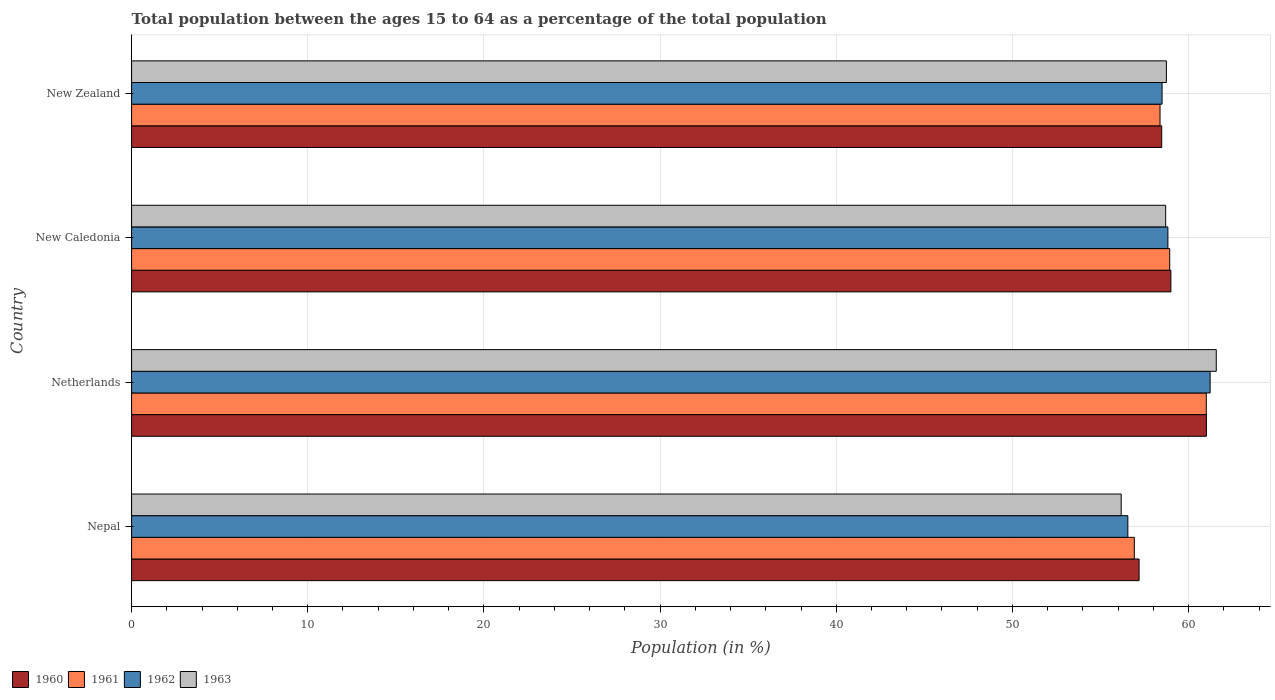Are the number of bars per tick equal to the number of legend labels?
Your answer should be compact. Yes. How many bars are there on the 2nd tick from the bottom?
Provide a short and direct response. 4. What is the label of the 2nd group of bars from the top?
Give a very brief answer. New Caledonia. In how many cases, is the number of bars for a given country not equal to the number of legend labels?
Your response must be concise. 0. What is the percentage of the population ages 15 to 64 in 1961 in New Caledonia?
Give a very brief answer. 58.93. Across all countries, what is the maximum percentage of the population ages 15 to 64 in 1963?
Ensure brevity in your answer.  61.57. Across all countries, what is the minimum percentage of the population ages 15 to 64 in 1962?
Your answer should be compact. 56.55. In which country was the percentage of the population ages 15 to 64 in 1961 maximum?
Give a very brief answer. Netherlands. In which country was the percentage of the population ages 15 to 64 in 1962 minimum?
Keep it short and to the point. Nepal. What is the total percentage of the population ages 15 to 64 in 1960 in the graph?
Keep it short and to the point. 235.67. What is the difference between the percentage of the population ages 15 to 64 in 1962 in New Caledonia and that in New Zealand?
Give a very brief answer. 0.33. What is the difference between the percentage of the population ages 15 to 64 in 1963 in Netherlands and the percentage of the population ages 15 to 64 in 1960 in Nepal?
Ensure brevity in your answer.  4.38. What is the average percentage of the population ages 15 to 64 in 1962 per country?
Ensure brevity in your answer.  58.77. What is the difference between the percentage of the population ages 15 to 64 in 1960 and percentage of the population ages 15 to 64 in 1961 in Nepal?
Provide a succinct answer. 0.27. What is the ratio of the percentage of the population ages 15 to 64 in 1962 in Netherlands to that in New Caledonia?
Offer a very short reply. 1.04. What is the difference between the highest and the second highest percentage of the population ages 15 to 64 in 1963?
Offer a very short reply. 2.83. What is the difference between the highest and the lowest percentage of the population ages 15 to 64 in 1963?
Give a very brief answer. 5.4. In how many countries, is the percentage of the population ages 15 to 64 in 1962 greater than the average percentage of the population ages 15 to 64 in 1962 taken over all countries?
Make the answer very short. 2. Is the sum of the percentage of the population ages 15 to 64 in 1960 in Nepal and New Zealand greater than the maximum percentage of the population ages 15 to 64 in 1962 across all countries?
Your response must be concise. Yes. Is it the case that in every country, the sum of the percentage of the population ages 15 to 64 in 1961 and percentage of the population ages 15 to 64 in 1963 is greater than the percentage of the population ages 15 to 64 in 1960?
Ensure brevity in your answer.  Yes. What is the difference between two consecutive major ticks on the X-axis?
Give a very brief answer. 10. Are the values on the major ticks of X-axis written in scientific E-notation?
Provide a short and direct response. No. How many legend labels are there?
Keep it short and to the point. 4. How are the legend labels stacked?
Your answer should be compact. Horizontal. What is the title of the graph?
Ensure brevity in your answer.  Total population between the ages 15 to 64 as a percentage of the total population. Does "1992" appear as one of the legend labels in the graph?
Make the answer very short. No. What is the label or title of the X-axis?
Provide a succinct answer. Population (in %). What is the Population (in %) of 1960 in Nepal?
Your answer should be compact. 57.19. What is the Population (in %) in 1961 in Nepal?
Ensure brevity in your answer.  56.92. What is the Population (in %) in 1962 in Nepal?
Offer a very short reply. 56.55. What is the Population (in %) of 1963 in Nepal?
Give a very brief answer. 56.17. What is the Population (in %) in 1960 in Netherlands?
Your answer should be compact. 61.01. What is the Population (in %) in 1961 in Netherlands?
Your answer should be compact. 61. What is the Population (in %) in 1962 in Netherlands?
Your response must be concise. 61.22. What is the Population (in %) in 1963 in Netherlands?
Keep it short and to the point. 61.57. What is the Population (in %) in 1960 in New Caledonia?
Your answer should be very brief. 58.99. What is the Population (in %) in 1961 in New Caledonia?
Provide a short and direct response. 58.93. What is the Population (in %) of 1962 in New Caledonia?
Provide a succinct answer. 58.82. What is the Population (in %) of 1963 in New Caledonia?
Offer a very short reply. 58.7. What is the Population (in %) in 1960 in New Zealand?
Ensure brevity in your answer.  58.47. What is the Population (in %) in 1961 in New Zealand?
Offer a terse response. 58.38. What is the Population (in %) in 1962 in New Zealand?
Provide a succinct answer. 58.49. What is the Population (in %) of 1963 in New Zealand?
Ensure brevity in your answer.  58.74. Across all countries, what is the maximum Population (in %) in 1960?
Provide a succinct answer. 61.01. Across all countries, what is the maximum Population (in %) of 1961?
Offer a terse response. 61. Across all countries, what is the maximum Population (in %) of 1962?
Give a very brief answer. 61.22. Across all countries, what is the maximum Population (in %) in 1963?
Keep it short and to the point. 61.57. Across all countries, what is the minimum Population (in %) of 1960?
Provide a succinct answer. 57.19. Across all countries, what is the minimum Population (in %) of 1961?
Provide a succinct answer. 56.92. Across all countries, what is the minimum Population (in %) in 1962?
Provide a succinct answer. 56.55. Across all countries, what is the minimum Population (in %) of 1963?
Your response must be concise. 56.17. What is the total Population (in %) in 1960 in the graph?
Make the answer very short. 235.67. What is the total Population (in %) in 1961 in the graph?
Provide a succinct answer. 235.23. What is the total Population (in %) in 1962 in the graph?
Your answer should be very brief. 235.09. What is the total Population (in %) in 1963 in the graph?
Keep it short and to the point. 235.18. What is the difference between the Population (in %) in 1960 in Nepal and that in Netherlands?
Provide a short and direct response. -3.82. What is the difference between the Population (in %) of 1961 in Nepal and that in Netherlands?
Your response must be concise. -4.08. What is the difference between the Population (in %) of 1962 in Nepal and that in Netherlands?
Your response must be concise. -4.67. What is the difference between the Population (in %) of 1963 in Nepal and that in Netherlands?
Offer a terse response. -5.4. What is the difference between the Population (in %) of 1960 in Nepal and that in New Caledonia?
Give a very brief answer. -1.8. What is the difference between the Population (in %) of 1961 in Nepal and that in New Caledonia?
Make the answer very short. -2.01. What is the difference between the Population (in %) in 1962 in Nepal and that in New Caledonia?
Give a very brief answer. -2.27. What is the difference between the Population (in %) in 1963 in Nepal and that in New Caledonia?
Give a very brief answer. -2.53. What is the difference between the Population (in %) in 1960 in Nepal and that in New Zealand?
Your answer should be very brief. -1.28. What is the difference between the Population (in %) of 1961 in Nepal and that in New Zealand?
Ensure brevity in your answer.  -1.46. What is the difference between the Population (in %) of 1962 in Nepal and that in New Zealand?
Your response must be concise. -1.94. What is the difference between the Population (in %) in 1963 in Nepal and that in New Zealand?
Make the answer very short. -2.57. What is the difference between the Population (in %) of 1960 in Netherlands and that in New Caledonia?
Keep it short and to the point. 2.02. What is the difference between the Population (in %) of 1961 in Netherlands and that in New Caledonia?
Offer a terse response. 2.08. What is the difference between the Population (in %) in 1962 in Netherlands and that in New Caledonia?
Your response must be concise. 2.4. What is the difference between the Population (in %) of 1963 in Netherlands and that in New Caledonia?
Provide a short and direct response. 2.87. What is the difference between the Population (in %) in 1960 in Netherlands and that in New Zealand?
Offer a very short reply. 2.54. What is the difference between the Population (in %) of 1961 in Netherlands and that in New Zealand?
Provide a short and direct response. 2.63. What is the difference between the Population (in %) of 1962 in Netherlands and that in New Zealand?
Offer a terse response. 2.73. What is the difference between the Population (in %) in 1963 in Netherlands and that in New Zealand?
Give a very brief answer. 2.83. What is the difference between the Population (in %) in 1960 in New Caledonia and that in New Zealand?
Your answer should be compact. 0.52. What is the difference between the Population (in %) of 1961 in New Caledonia and that in New Zealand?
Provide a short and direct response. 0.55. What is the difference between the Population (in %) of 1962 in New Caledonia and that in New Zealand?
Ensure brevity in your answer.  0.33. What is the difference between the Population (in %) of 1963 in New Caledonia and that in New Zealand?
Keep it short and to the point. -0.04. What is the difference between the Population (in %) of 1960 in Nepal and the Population (in %) of 1961 in Netherlands?
Provide a succinct answer. -3.81. What is the difference between the Population (in %) in 1960 in Nepal and the Population (in %) in 1962 in Netherlands?
Your response must be concise. -4.03. What is the difference between the Population (in %) of 1960 in Nepal and the Population (in %) of 1963 in Netherlands?
Ensure brevity in your answer.  -4.38. What is the difference between the Population (in %) in 1961 in Nepal and the Population (in %) in 1962 in Netherlands?
Provide a succinct answer. -4.3. What is the difference between the Population (in %) in 1961 in Nepal and the Population (in %) in 1963 in Netherlands?
Offer a very short reply. -4.65. What is the difference between the Population (in %) in 1962 in Nepal and the Population (in %) in 1963 in Netherlands?
Your answer should be compact. -5.02. What is the difference between the Population (in %) of 1960 in Nepal and the Population (in %) of 1961 in New Caledonia?
Your answer should be compact. -1.74. What is the difference between the Population (in %) in 1960 in Nepal and the Population (in %) in 1962 in New Caledonia?
Offer a very short reply. -1.63. What is the difference between the Population (in %) of 1960 in Nepal and the Population (in %) of 1963 in New Caledonia?
Make the answer very short. -1.51. What is the difference between the Population (in %) in 1961 in Nepal and the Population (in %) in 1962 in New Caledonia?
Ensure brevity in your answer.  -1.91. What is the difference between the Population (in %) of 1961 in Nepal and the Population (in %) of 1963 in New Caledonia?
Your answer should be very brief. -1.78. What is the difference between the Population (in %) of 1962 in Nepal and the Population (in %) of 1963 in New Caledonia?
Your response must be concise. -2.15. What is the difference between the Population (in %) in 1960 in Nepal and the Population (in %) in 1961 in New Zealand?
Provide a short and direct response. -1.19. What is the difference between the Population (in %) of 1960 in Nepal and the Population (in %) of 1962 in New Zealand?
Your response must be concise. -1.3. What is the difference between the Population (in %) of 1960 in Nepal and the Population (in %) of 1963 in New Zealand?
Make the answer very short. -1.55. What is the difference between the Population (in %) of 1961 in Nepal and the Population (in %) of 1962 in New Zealand?
Provide a short and direct response. -1.57. What is the difference between the Population (in %) of 1961 in Nepal and the Population (in %) of 1963 in New Zealand?
Your response must be concise. -1.82. What is the difference between the Population (in %) in 1962 in Nepal and the Population (in %) in 1963 in New Zealand?
Provide a succinct answer. -2.19. What is the difference between the Population (in %) of 1960 in Netherlands and the Population (in %) of 1961 in New Caledonia?
Your answer should be compact. 2.08. What is the difference between the Population (in %) of 1960 in Netherlands and the Population (in %) of 1962 in New Caledonia?
Your answer should be very brief. 2.19. What is the difference between the Population (in %) of 1960 in Netherlands and the Population (in %) of 1963 in New Caledonia?
Provide a succinct answer. 2.31. What is the difference between the Population (in %) in 1961 in Netherlands and the Population (in %) in 1962 in New Caledonia?
Offer a terse response. 2.18. What is the difference between the Population (in %) of 1961 in Netherlands and the Population (in %) of 1963 in New Caledonia?
Provide a succinct answer. 2.31. What is the difference between the Population (in %) in 1962 in Netherlands and the Population (in %) in 1963 in New Caledonia?
Give a very brief answer. 2.52. What is the difference between the Population (in %) of 1960 in Netherlands and the Population (in %) of 1961 in New Zealand?
Your response must be concise. 2.63. What is the difference between the Population (in %) in 1960 in Netherlands and the Population (in %) in 1962 in New Zealand?
Provide a short and direct response. 2.52. What is the difference between the Population (in %) of 1960 in Netherlands and the Population (in %) of 1963 in New Zealand?
Provide a short and direct response. 2.27. What is the difference between the Population (in %) in 1961 in Netherlands and the Population (in %) in 1962 in New Zealand?
Keep it short and to the point. 2.51. What is the difference between the Population (in %) in 1961 in Netherlands and the Population (in %) in 1963 in New Zealand?
Offer a very short reply. 2.26. What is the difference between the Population (in %) in 1962 in Netherlands and the Population (in %) in 1963 in New Zealand?
Your answer should be very brief. 2.48. What is the difference between the Population (in %) in 1960 in New Caledonia and the Population (in %) in 1961 in New Zealand?
Offer a terse response. 0.62. What is the difference between the Population (in %) of 1960 in New Caledonia and the Population (in %) of 1962 in New Zealand?
Provide a succinct answer. 0.5. What is the difference between the Population (in %) in 1960 in New Caledonia and the Population (in %) in 1963 in New Zealand?
Keep it short and to the point. 0.25. What is the difference between the Population (in %) in 1961 in New Caledonia and the Population (in %) in 1962 in New Zealand?
Your answer should be compact. 0.43. What is the difference between the Population (in %) in 1961 in New Caledonia and the Population (in %) in 1963 in New Zealand?
Your answer should be very brief. 0.19. What is the difference between the Population (in %) of 1962 in New Caledonia and the Population (in %) of 1963 in New Zealand?
Provide a short and direct response. 0.08. What is the average Population (in %) in 1960 per country?
Make the answer very short. 58.92. What is the average Population (in %) of 1961 per country?
Make the answer very short. 58.81. What is the average Population (in %) in 1962 per country?
Your response must be concise. 58.77. What is the average Population (in %) in 1963 per country?
Keep it short and to the point. 58.8. What is the difference between the Population (in %) of 1960 and Population (in %) of 1961 in Nepal?
Offer a very short reply. 0.27. What is the difference between the Population (in %) of 1960 and Population (in %) of 1962 in Nepal?
Provide a short and direct response. 0.64. What is the difference between the Population (in %) in 1960 and Population (in %) in 1963 in Nepal?
Your answer should be very brief. 1.02. What is the difference between the Population (in %) in 1961 and Population (in %) in 1962 in Nepal?
Provide a short and direct response. 0.37. What is the difference between the Population (in %) of 1961 and Population (in %) of 1963 in Nepal?
Keep it short and to the point. 0.75. What is the difference between the Population (in %) in 1962 and Population (in %) in 1963 in Nepal?
Your response must be concise. 0.38. What is the difference between the Population (in %) of 1960 and Population (in %) of 1961 in Netherlands?
Offer a terse response. 0.01. What is the difference between the Population (in %) of 1960 and Population (in %) of 1962 in Netherlands?
Give a very brief answer. -0.21. What is the difference between the Population (in %) in 1960 and Population (in %) in 1963 in Netherlands?
Provide a succinct answer. -0.56. What is the difference between the Population (in %) of 1961 and Population (in %) of 1962 in Netherlands?
Ensure brevity in your answer.  -0.22. What is the difference between the Population (in %) in 1961 and Population (in %) in 1963 in Netherlands?
Make the answer very short. -0.57. What is the difference between the Population (in %) in 1962 and Population (in %) in 1963 in Netherlands?
Ensure brevity in your answer.  -0.35. What is the difference between the Population (in %) in 1960 and Population (in %) in 1961 in New Caledonia?
Keep it short and to the point. 0.07. What is the difference between the Population (in %) in 1960 and Population (in %) in 1962 in New Caledonia?
Your response must be concise. 0.17. What is the difference between the Population (in %) in 1960 and Population (in %) in 1963 in New Caledonia?
Offer a terse response. 0.29. What is the difference between the Population (in %) in 1961 and Population (in %) in 1962 in New Caledonia?
Keep it short and to the point. 0.1. What is the difference between the Population (in %) in 1961 and Population (in %) in 1963 in New Caledonia?
Keep it short and to the point. 0.23. What is the difference between the Population (in %) of 1962 and Population (in %) of 1963 in New Caledonia?
Ensure brevity in your answer.  0.13. What is the difference between the Population (in %) of 1960 and Population (in %) of 1961 in New Zealand?
Offer a terse response. 0.1. What is the difference between the Population (in %) of 1960 and Population (in %) of 1962 in New Zealand?
Give a very brief answer. -0.02. What is the difference between the Population (in %) in 1960 and Population (in %) in 1963 in New Zealand?
Your answer should be compact. -0.27. What is the difference between the Population (in %) in 1961 and Population (in %) in 1962 in New Zealand?
Offer a terse response. -0.12. What is the difference between the Population (in %) in 1961 and Population (in %) in 1963 in New Zealand?
Give a very brief answer. -0.36. What is the difference between the Population (in %) in 1962 and Population (in %) in 1963 in New Zealand?
Offer a terse response. -0.25. What is the ratio of the Population (in %) in 1960 in Nepal to that in Netherlands?
Your answer should be compact. 0.94. What is the ratio of the Population (in %) in 1961 in Nepal to that in Netherlands?
Your answer should be compact. 0.93. What is the ratio of the Population (in %) of 1962 in Nepal to that in Netherlands?
Ensure brevity in your answer.  0.92. What is the ratio of the Population (in %) of 1963 in Nepal to that in Netherlands?
Offer a terse response. 0.91. What is the ratio of the Population (in %) of 1960 in Nepal to that in New Caledonia?
Offer a very short reply. 0.97. What is the ratio of the Population (in %) in 1961 in Nepal to that in New Caledonia?
Give a very brief answer. 0.97. What is the ratio of the Population (in %) of 1962 in Nepal to that in New Caledonia?
Offer a very short reply. 0.96. What is the ratio of the Population (in %) in 1963 in Nepal to that in New Caledonia?
Ensure brevity in your answer.  0.96. What is the ratio of the Population (in %) in 1961 in Nepal to that in New Zealand?
Provide a succinct answer. 0.97. What is the ratio of the Population (in %) in 1962 in Nepal to that in New Zealand?
Your answer should be compact. 0.97. What is the ratio of the Population (in %) of 1963 in Nepal to that in New Zealand?
Make the answer very short. 0.96. What is the ratio of the Population (in %) of 1960 in Netherlands to that in New Caledonia?
Your response must be concise. 1.03. What is the ratio of the Population (in %) of 1961 in Netherlands to that in New Caledonia?
Ensure brevity in your answer.  1.04. What is the ratio of the Population (in %) in 1962 in Netherlands to that in New Caledonia?
Your answer should be compact. 1.04. What is the ratio of the Population (in %) in 1963 in Netherlands to that in New Caledonia?
Your answer should be compact. 1.05. What is the ratio of the Population (in %) in 1960 in Netherlands to that in New Zealand?
Give a very brief answer. 1.04. What is the ratio of the Population (in %) in 1961 in Netherlands to that in New Zealand?
Your answer should be compact. 1.04. What is the ratio of the Population (in %) of 1962 in Netherlands to that in New Zealand?
Keep it short and to the point. 1.05. What is the ratio of the Population (in %) in 1963 in Netherlands to that in New Zealand?
Your answer should be very brief. 1.05. What is the ratio of the Population (in %) in 1960 in New Caledonia to that in New Zealand?
Your answer should be compact. 1.01. What is the ratio of the Population (in %) of 1961 in New Caledonia to that in New Zealand?
Your answer should be very brief. 1.01. What is the ratio of the Population (in %) in 1962 in New Caledonia to that in New Zealand?
Offer a terse response. 1.01. What is the difference between the highest and the second highest Population (in %) of 1960?
Make the answer very short. 2.02. What is the difference between the highest and the second highest Population (in %) in 1961?
Ensure brevity in your answer.  2.08. What is the difference between the highest and the second highest Population (in %) of 1962?
Provide a short and direct response. 2.4. What is the difference between the highest and the second highest Population (in %) in 1963?
Ensure brevity in your answer.  2.83. What is the difference between the highest and the lowest Population (in %) in 1960?
Keep it short and to the point. 3.82. What is the difference between the highest and the lowest Population (in %) in 1961?
Keep it short and to the point. 4.08. What is the difference between the highest and the lowest Population (in %) in 1962?
Your answer should be compact. 4.67. What is the difference between the highest and the lowest Population (in %) in 1963?
Give a very brief answer. 5.4. 